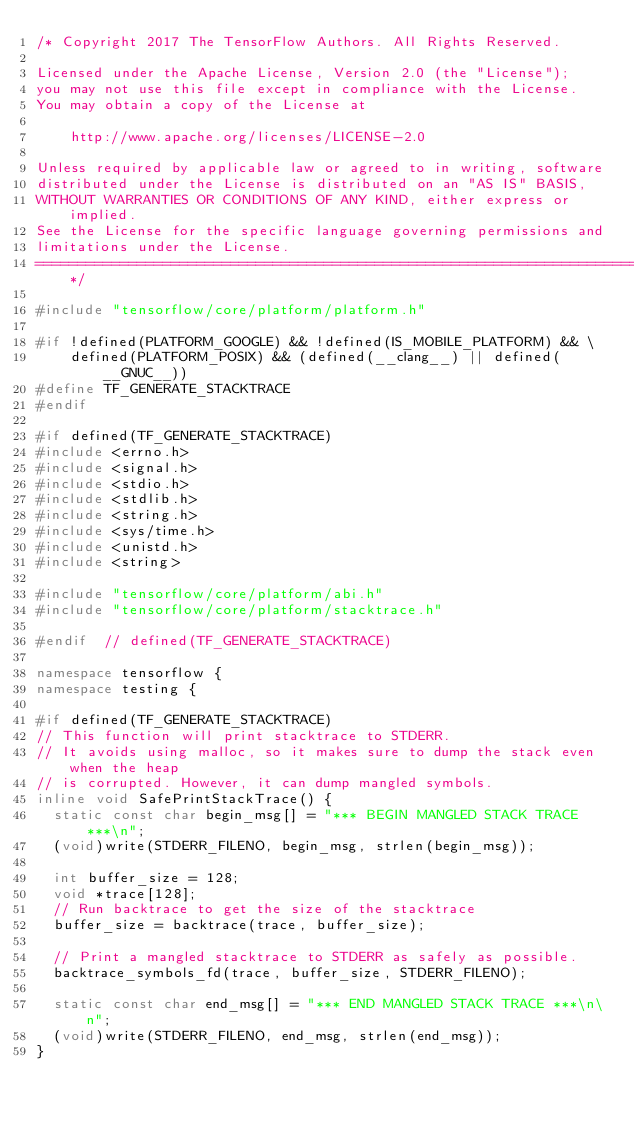<code> <loc_0><loc_0><loc_500><loc_500><_C++_>/* Copyright 2017 The TensorFlow Authors. All Rights Reserved.

Licensed under the Apache License, Version 2.0 (the "License");
you may not use this file except in compliance with the License.
You may obtain a copy of the License at

    http://www.apache.org/licenses/LICENSE-2.0

Unless required by applicable law or agreed to in writing, software
distributed under the License is distributed on an "AS IS" BASIS,
WITHOUT WARRANTIES OR CONDITIONS OF ANY KIND, either express or implied.
See the License for the specific language governing permissions and
limitations under the License.
==============================================================================*/

#include "tensorflow/core/platform/platform.h"

#if !defined(PLATFORM_GOOGLE) && !defined(IS_MOBILE_PLATFORM) && \
    defined(PLATFORM_POSIX) && (defined(__clang__) || defined(__GNUC__))
#define TF_GENERATE_STACKTRACE
#endif

#if defined(TF_GENERATE_STACKTRACE)
#include <errno.h>
#include <signal.h>
#include <stdio.h>
#include <stdlib.h>
#include <string.h>
#include <sys/time.h>
#include <unistd.h>
#include <string>

#include "tensorflow/core/platform/abi.h"
#include "tensorflow/core/platform/stacktrace.h"

#endif  // defined(TF_GENERATE_STACKTRACE)

namespace tensorflow {
namespace testing {

#if defined(TF_GENERATE_STACKTRACE)
// This function will print stacktrace to STDERR.
// It avoids using malloc, so it makes sure to dump the stack even when the heap
// is corrupted. However, it can dump mangled symbols.
inline void SafePrintStackTrace() {
  static const char begin_msg[] = "*** BEGIN MANGLED STACK TRACE ***\n";
  (void)write(STDERR_FILENO, begin_msg, strlen(begin_msg));

  int buffer_size = 128;
  void *trace[128];
  // Run backtrace to get the size of the stacktrace
  buffer_size = backtrace(trace, buffer_size);

  // Print a mangled stacktrace to STDERR as safely as possible.
  backtrace_symbols_fd(trace, buffer_size, STDERR_FILENO);

  static const char end_msg[] = "*** END MANGLED STACK TRACE ***\n\n";
  (void)write(STDERR_FILENO, end_msg, strlen(end_msg));
}
</code> 